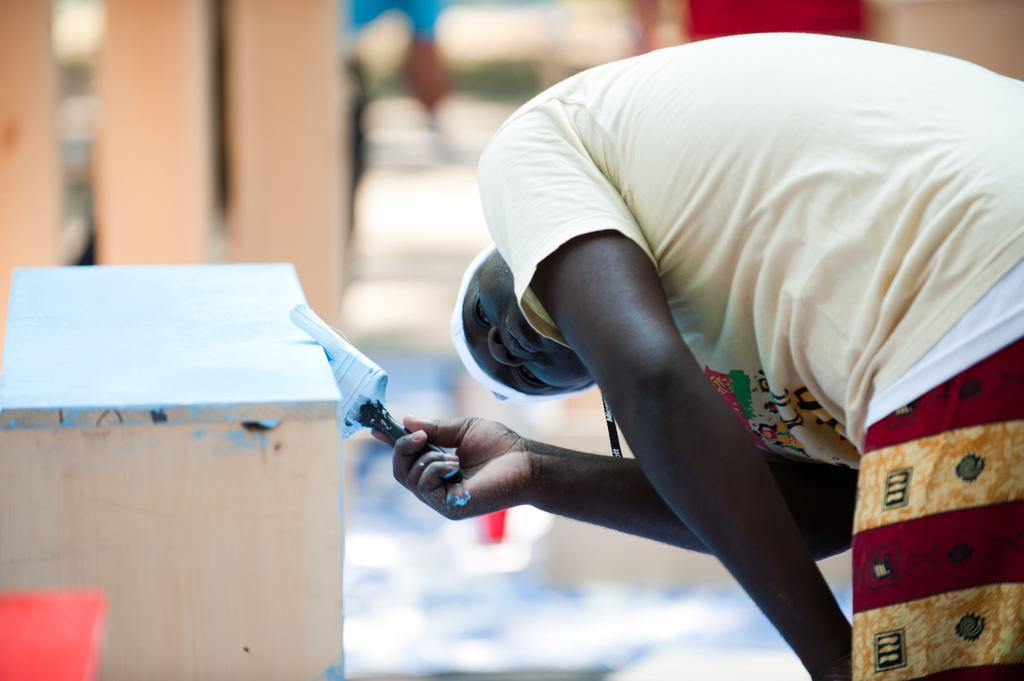What is the main subject of the image? There is a person in the image. What is the person doing in the image? The person is standing and holding a brush. What can be seen in the bottom left side of the image? There is a table in the bottom left side of the image. Can you describe the area behind the table? The area behind the table is blurred. What type of bead is the person using to spy on the quince in the image? There is no bead or quince present in the image, and the person is not depicted as spying on anything. 